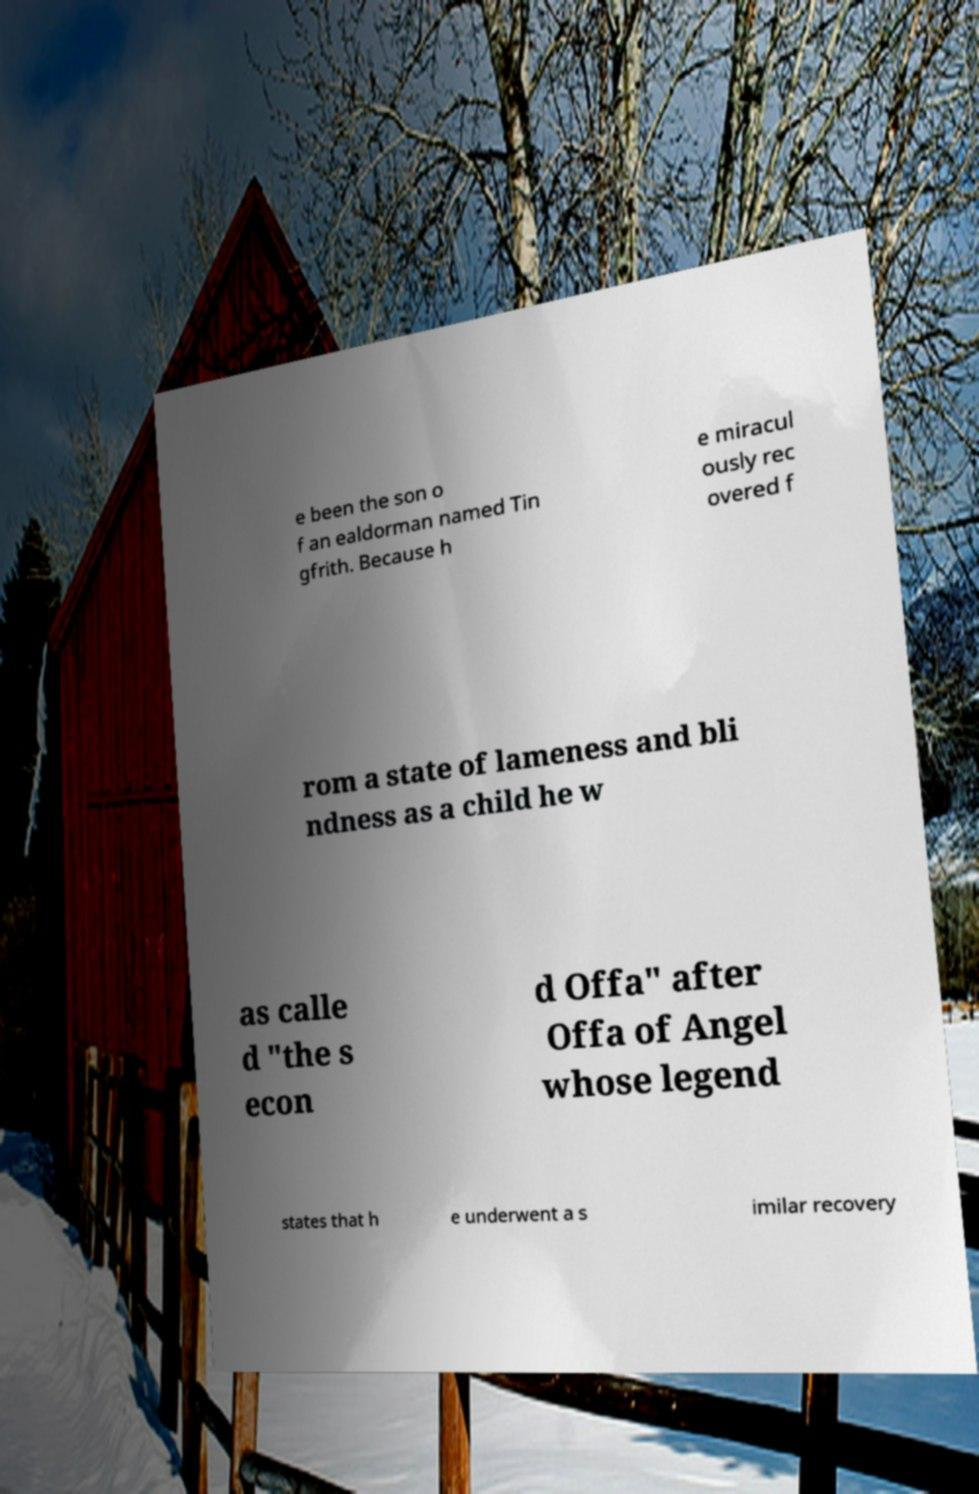I need the written content from this picture converted into text. Can you do that? e been the son o f an ealdorman named Tin gfrith. Because h e miracul ously rec overed f rom a state of lameness and bli ndness as a child he w as calle d "the s econ d Offa" after Offa of Angel whose legend states that h e underwent a s imilar recovery 